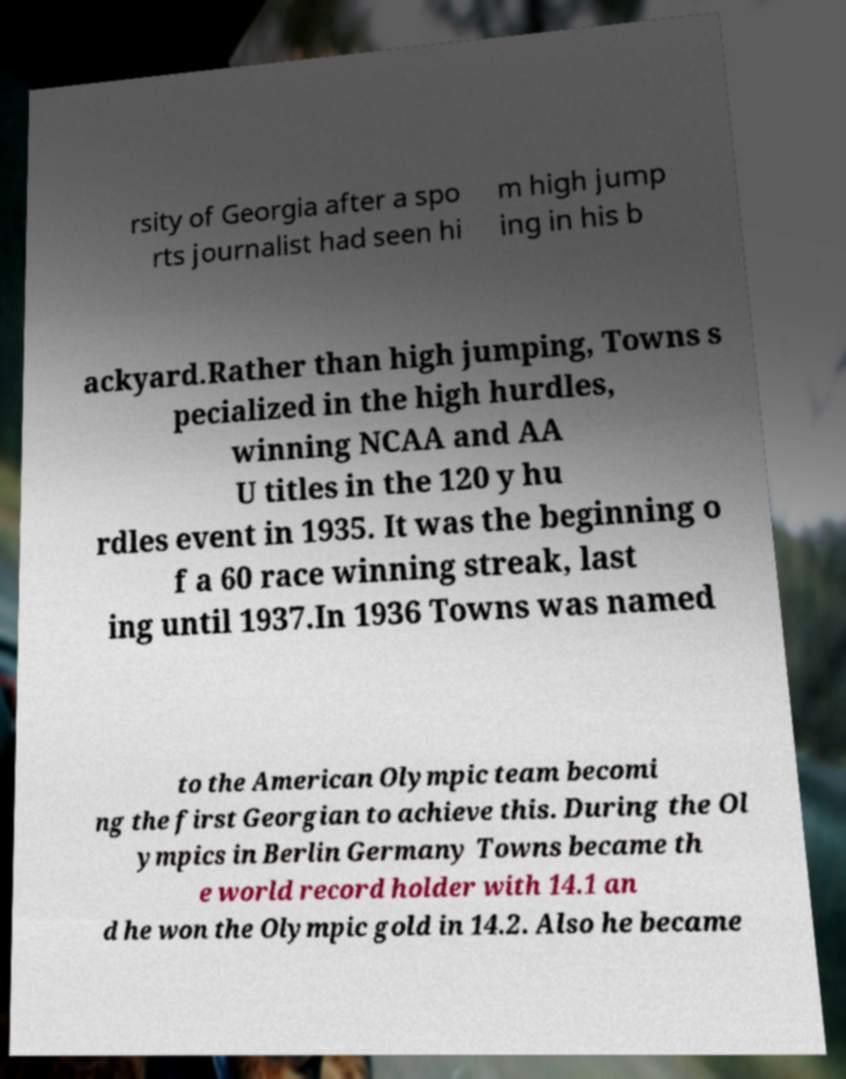Please read and relay the text visible in this image. What does it say? rsity of Georgia after a spo rts journalist had seen hi m high jump ing in his b ackyard.Rather than high jumping, Towns s pecialized in the high hurdles, winning NCAA and AA U titles in the 120 y hu rdles event in 1935. It was the beginning o f a 60 race winning streak, last ing until 1937.In 1936 Towns was named to the American Olympic team becomi ng the first Georgian to achieve this. During the Ol ympics in Berlin Germany Towns became th e world record holder with 14.1 an d he won the Olympic gold in 14.2. Also he became 